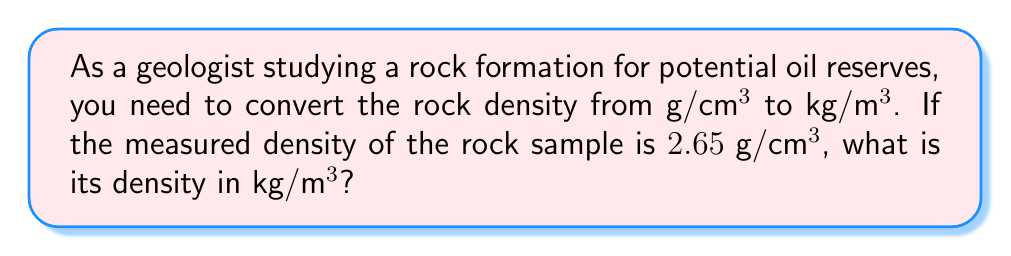Help me with this question. To convert the density from $\text{g}/\text{cm}^3$ to $\text{kg}/\text{m}^3$, we need to follow these steps:

1. Understand the conversion factors:
   - 1 kg = 1000 g
   - 1 m = 100 cm

2. Set up the conversion:
   $2.65 \text{ g}/\text{cm}^3 \times (\text{conversion factor})$

3. Convert grams to kilograms:
   $2.65 \text{ g}/\text{cm}^3 \times (1 \text{ kg} / 1000 \text{ g})$

4. Convert cubic centimeters to cubic meters:
   $2.65 \text{ g}/\text{cm}^3 \times (1 \text{ kg} / 1000 \text{ g}) \times (100 \text{ cm} / 1 \text{ m})^3$

5. Simplify:
   $2.65 \times (1/1000) \times (100^3) = 2.65 \times 0.001 \times 1,000,000 = 2650$

Therefore, the density in $\text{kg}/\text{m}^3$ is 2650.
Answer: $2650 \text{ kg}/\text{m}^3$ 